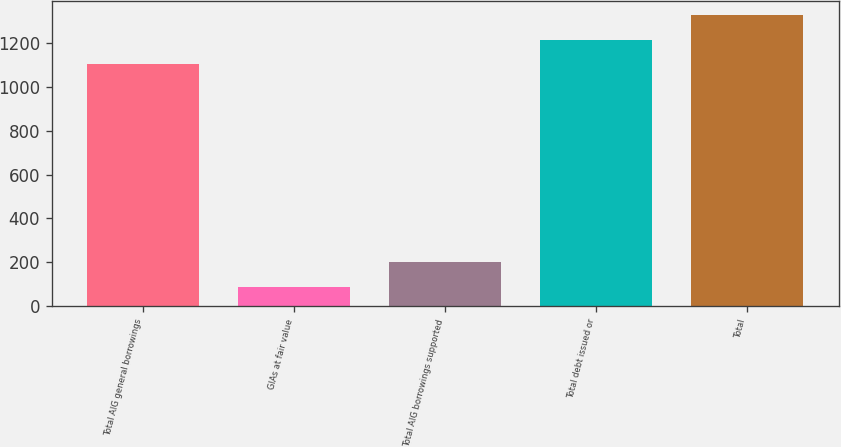<chart> <loc_0><loc_0><loc_500><loc_500><bar_chart><fcel>Total AIG general borrowings<fcel>GIAs at fair value<fcel>Total AIG borrowings supported<fcel>Total debt issued or<fcel>Total<nl><fcel>1105<fcel>90<fcel>200.5<fcel>1215.5<fcel>1326<nl></chart> 